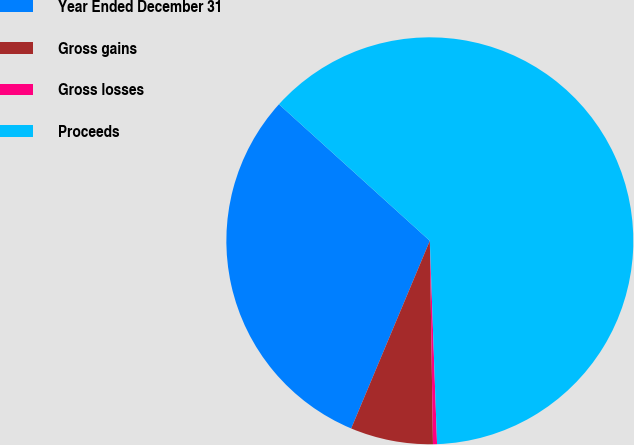Convert chart. <chart><loc_0><loc_0><loc_500><loc_500><pie_chart><fcel>Year Ended December 31<fcel>Gross gains<fcel>Gross losses<fcel>Proceeds<nl><fcel>30.39%<fcel>6.56%<fcel>0.32%<fcel>62.73%<nl></chart> 